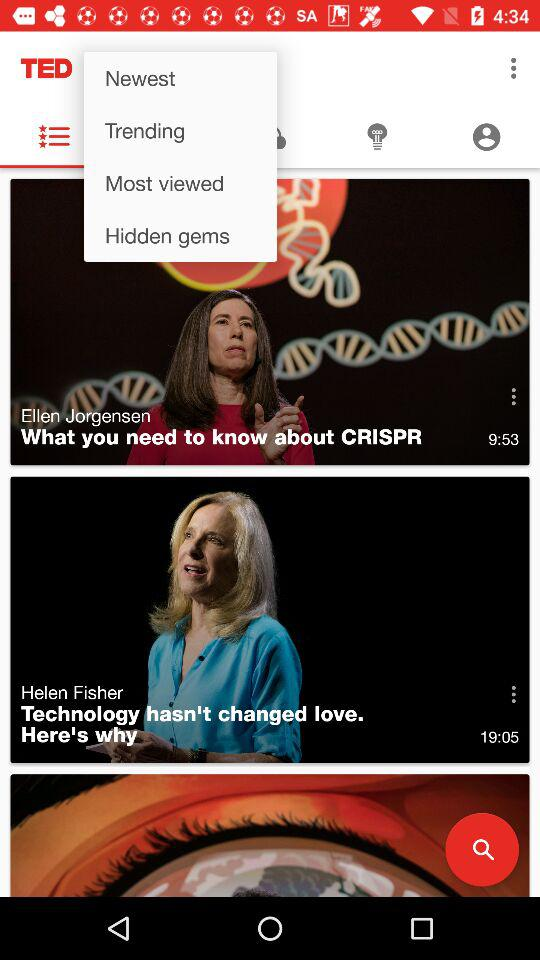What is the duration of Helen Fisher's video? The duration is 19 minutes and 5 seconds. 